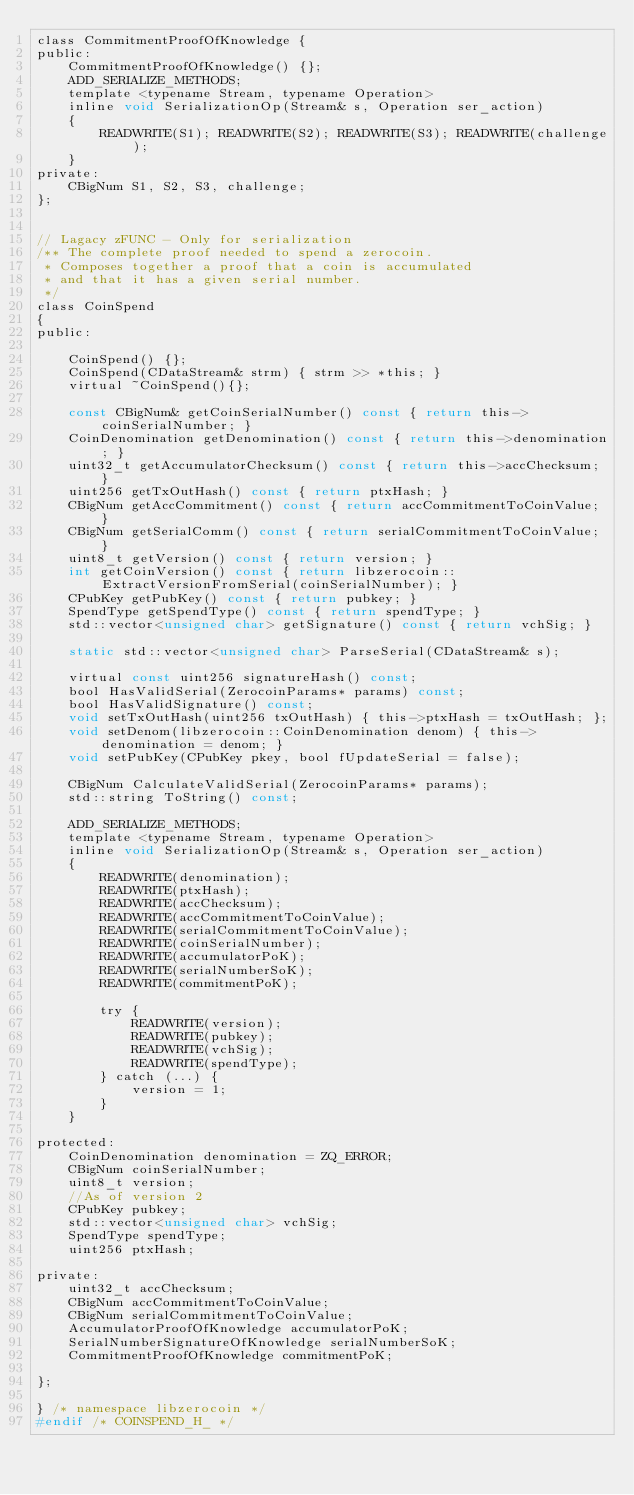<code> <loc_0><loc_0><loc_500><loc_500><_C_>class CommitmentProofOfKnowledge {
public:
    CommitmentProofOfKnowledge() {};
    ADD_SERIALIZE_METHODS;
    template <typename Stream, typename Operation>
    inline void SerializationOp(Stream& s, Operation ser_action)
    {
        READWRITE(S1); READWRITE(S2); READWRITE(S3); READWRITE(challenge);
    }
private:
    CBigNum S1, S2, S3, challenge;
};


// Lagacy zFUNC - Only for serialization
/** The complete proof needed to spend a zerocoin.
 * Composes together a proof that a coin is accumulated
 * and that it has a given serial number.
 */
class CoinSpend
{
public:

    CoinSpend() {};
    CoinSpend(CDataStream& strm) { strm >> *this; }
    virtual ~CoinSpend(){};

    const CBigNum& getCoinSerialNumber() const { return this->coinSerialNumber; }
    CoinDenomination getDenomination() const { return this->denomination; }
    uint32_t getAccumulatorChecksum() const { return this->accChecksum; }
    uint256 getTxOutHash() const { return ptxHash; }
    CBigNum getAccCommitment() const { return accCommitmentToCoinValue; }
    CBigNum getSerialComm() const { return serialCommitmentToCoinValue; }
    uint8_t getVersion() const { return version; }
    int getCoinVersion() const { return libzerocoin::ExtractVersionFromSerial(coinSerialNumber); }
    CPubKey getPubKey() const { return pubkey; }
    SpendType getSpendType() const { return spendType; }
    std::vector<unsigned char> getSignature() const { return vchSig; }

    static std::vector<unsigned char> ParseSerial(CDataStream& s);

    virtual const uint256 signatureHash() const;
    bool HasValidSerial(ZerocoinParams* params) const;
    bool HasValidSignature() const;
    void setTxOutHash(uint256 txOutHash) { this->ptxHash = txOutHash; };
    void setDenom(libzerocoin::CoinDenomination denom) { this->denomination = denom; }
    void setPubKey(CPubKey pkey, bool fUpdateSerial = false);

    CBigNum CalculateValidSerial(ZerocoinParams* params);
    std::string ToString() const;

    ADD_SERIALIZE_METHODS;
    template <typename Stream, typename Operation>
    inline void SerializationOp(Stream& s, Operation ser_action)
    {
        READWRITE(denomination);
        READWRITE(ptxHash);
        READWRITE(accChecksum);
        READWRITE(accCommitmentToCoinValue);
        READWRITE(serialCommitmentToCoinValue);
        READWRITE(coinSerialNumber);
        READWRITE(accumulatorPoK);
        READWRITE(serialNumberSoK);
        READWRITE(commitmentPoK);

        try {
            READWRITE(version);
            READWRITE(pubkey);
            READWRITE(vchSig);
            READWRITE(spendType);
        } catch (...) {
            version = 1;
        }
    }

protected:
    CoinDenomination denomination = ZQ_ERROR;
    CBigNum coinSerialNumber;
    uint8_t version;
    //As of version 2
    CPubKey pubkey;
    std::vector<unsigned char> vchSig;
    SpendType spendType;
    uint256 ptxHash;

private:
    uint32_t accChecksum;
    CBigNum accCommitmentToCoinValue;
    CBigNum serialCommitmentToCoinValue;
    AccumulatorProofOfKnowledge accumulatorPoK;
    SerialNumberSignatureOfKnowledge serialNumberSoK;
    CommitmentProofOfKnowledge commitmentPoK;

};

} /* namespace libzerocoin */
#endif /* COINSPEND_H_ */
</code> 